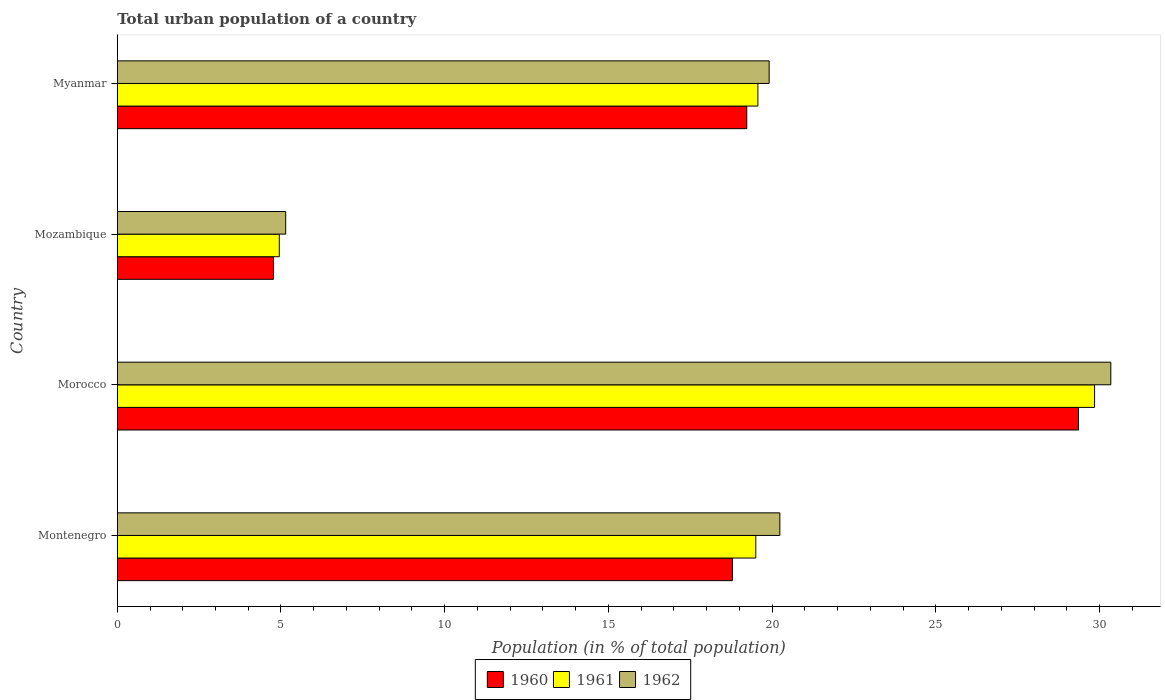How many bars are there on the 3rd tick from the top?
Your answer should be very brief. 3. How many bars are there on the 1st tick from the bottom?
Provide a succinct answer. 3. What is the label of the 1st group of bars from the top?
Your answer should be compact. Myanmar. What is the urban population in 1960 in Myanmar?
Provide a short and direct response. 19.23. Across all countries, what is the maximum urban population in 1960?
Offer a very short reply. 29.36. Across all countries, what is the minimum urban population in 1962?
Your response must be concise. 5.14. In which country was the urban population in 1960 maximum?
Your response must be concise. Morocco. In which country was the urban population in 1962 minimum?
Your answer should be compact. Mozambique. What is the total urban population in 1962 in the graph?
Make the answer very short. 75.64. What is the difference between the urban population in 1960 in Montenegro and that in Mozambique?
Provide a succinct answer. 14.02. What is the difference between the urban population in 1960 in Myanmar and the urban population in 1962 in Morocco?
Your answer should be compact. -11.12. What is the average urban population in 1961 per country?
Keep it short and to the point. 18.47. What is the difference between the urban population in 1962 and urban population in 1960 in Morocco?
Make the answer very short. 0.99. In how many countries, is the urban population in 1960 greater than 22 %?
Offer a very short reply. 1. What is the ratio of the urban population in 1962 in Montenegro to that in Morocco?
Provide a succinct answer. 0.67. Is the difference between the urban population in 1962 in Morocco and Myanmar greater than the difference between the urban population in 1960 in Morocco and Myanmar?
Provide a succinct answer. Yes. What is the difference between the highest and the second highest urban population in 1961?
Give a very brief answer. 10.28. What is the difference between the highest and the lowest urban population in 1961?
Provide a succinct answer. 24.9. In how many countries, is the urban population in 1960 greater than the average urban population in 1960 taken over all countries?
Keep it short and to the point. 3. What does the 1st bar from the bottom in Montenegro represents?
Keep it short and to the point. 1960. Is it the case that in every country, the sum of the urban population in 1961 and urban population in 1962 is greater than the urban population in 1960?
Offer a terse response. Yes. How many bars are there?
Make the answer very short. 12. What is the difference between two consecutive major ticks on the X-axis?
Provide a succinct answer. 5. Are the values on the major ticks of X-axis written in scientific E-notation?
Provide a succinct answer. No. Does the graph contain any zero values?
Your response must be concise. No. How are the legend labels stacked?
Offer a very short reply. Horizontal. What is the title of the graph?
Your answer should be compact. Total urban population of a country. Does "1969" appear as one of the legend labels in the graph?
Ensure brevity in your answer.  No. What is the label or title of the X-axis?
Your answer should be compact. Population (in % of total population). What is the Population (in % of total population) of 1960 in Montenegro?
Provide a short and direct response. 18.79. What is the Population (in % of total population) in 1961 in Montenegro?
Offer a terse response. 19.5. What is the Population (in % of total population) in 1962 in Montenegro?
Provide a succinct answer. 20.24. What is the Population (in % of total population) of 1960 in Morocco?
Ensure brevity in your answer.  29.36. What is the Population (in % of total population) in 1961 in Morocco?
Your answer should be compact. 29.85. What is the Population (in % of total population) of 1962 in Morocco?
Give a very brief answer. 30.34. What is the Population (in % of total population) in 1960 in Mozambique?
Keep it short and to the point. 4.77. What is the Population (in % of total population) of 1961 in Mozambique?
Provide a succinct answer. 4.95. What is the Population (in % of total population) of 1962 in Mozambique?
Your answer should be very brief. 5.14. What is the Population (in % of total population) in 1960 in Myanmar?
Offer a terse response. 19.23. What is the Population (in % of total population) in 1961 in Myanmar?
Offer a terse response. 19.57. What is the Population (in % of total population) of 1962 in Myanmar?
Offer a very short reply. 19.91. Across all countries, what is the maximum Population (in % of total population) in 1960?
Provide a succinct answer. 29.36. Across all countries, what is the maximum Population (in % of total population) in 1961?
Your answer should be very brief. 29.85. Across all countries, what is the maximum Population (in % of total population) in 1962?
Your answer should be compact. 30.34. Across all countries, what is the minimum Population (in % of total population) of 1960?
Your answer should be very brief. 4.77. Across all countries, what is the minimum Population (in % of total population) of 1961?
Give a very brief answer. 4.95. Across all countries, what is the minimum Population (in % of total population) of 1962?
Make the answer very short. 5.14. What is the total Population (in % of total population) in 1960 in the graph?
Your response must be concise. 72.14. What is the total Population (in % of total population) in 1961 in the graph?
Give a very brief answer. 73.87. What is the total Population (in % of total population) of 1962 in the graph?
Provide a succinct answer. 75.64. What is the difference between the Population (in % of total population) of 1960 in Montenegro and that in Morocco?
Make the answer very short. -10.57. What is the difference between the Population (in % of total population) in 1961 in Montenegro and that in Morocco?
Provide a short and direct response. -10.35. What is the difference between the Population (in % of total population) of 1962 in Montenegro and that in Morocco?
Keep it short and to the point. -10.11. What is the difference between the Population (in % of total population) in 1960 in Montenegro and that in Mozambique?
Give a very brief answer. 14.02. What is the difference between the Population (in % of total population) in 1961 in Montenegro and that in Mozambique?
Keep it short and to the point. 14.55. What is the difference between the Population (in % of total population) of 1962 in Montenegro and that in Mozambique?
Provide a short and direct response. 15.09. What is the difference between the Population (in % of total population) of 1960 in Montenegro and that in Myanmar?
Ensure brevity in your answer.  -0.44. What is the difference between the Population (in % of total population) of 1961 in Montenegro and that in Myanmar?
Provide a short and direct response. -0.06. What is the difference between the Population (in % of total population) of 1962 in Montenegro and that in Myanmar?
Offer a very short reply. 0.33. What is the difference between the Population (in % of total population) of 1960 in Morocco and that in Mozambique?
Offer a very short reply. 24.59. What is the difference between the Population (in % of total population) in 1961 in Morocco and that in Mozambique?
Offer a terse response. 24.9. What is the difference between the Population (in % of total population) in 1962 in Morocco and that in Mozambique?
Ensure brevity in your answer.  25.2. What is the difference between the Population (in % of total population) in 1960 in Morocco and that in Myanmar?
Provide a succinct answer. 10.13. What is the difference between the Population (in % of total population) in 1961 in Morocco and that in Myanmar?
Keep it short and to the point. 10.28. What is the difference between the Population (in % of total population) in 1962 in Morocco and that in Myanmar?
Your response must be concise. 10.44. What is the difference between the Population (in % of total population) of 1960 in Mozambique and that in Myanmar?
Make the answer very short. -14.46. What is the difference between the Population (in % of total population) in 1961 in Mozambique and that in Myanmar?
Provide a short and direct response. -14.62. What is the difference between the Population (in % of total population) of 1962 in Mozambique and that in Myanmar?
Provide a succinct answer. -14.77. What is the difference between the Population (in % of total population) of 1960 in Montenegro and the Population (in % of total population) of 1961 in Morocco?
Your answer should be compact. -11.06. What is the difference between the Population (in % of total population) in 1960 in Montenegro and the Population (in % of total population) in 1962 in Morocco?
Ensure brevity in your answer.  -11.56. What is the difference between the Population (in % of total population) in 1961 in Montenegro and the Population (in % of total population) in 1962 in Morocco?
Offer a very short reply. -10.84. What is the difference between the Population (in % of total population) of 1960 in Montenegro and the Population (in % of total population) of 1961 in Mozambique?
Your answer should be very brief. 13.84. What is the difference between the Population (in % of total population) in 1960 in Montenegro and the Population (in % of total population) in 1962 in Mozambique?
Keep it short and to the point. 13.64. What is the difference between the Population (in % of total population) of 1961 in Montenegro and the Population (in % of total population) of 1962 in Mozambique?
Give a very brief answer. 14.36. What is the difference between the Population (in % of total population) of 1960 in Montenegro and the Population (in % of total population) of 1961 in Myanmar?
Make the answer very short. -0.78. What is the difference between the Population (in % of total population) in 1960 in Montenegro and the Population (in % of total population) in 1962 in Myanmar?
Provide a short and direct response. -1.12. What is the difference between the Population (in % of total population) of 1961 in Montenegro and the Population (in % of total population) of 1962 in Myanmar?
Give a very brief answer. -0.41. What is the difference between the Population (in % of total population) of 1960 in Morocco and the Population (in % of total population) of 1961 in Mozambique?
Offer a terse response. 24.41. What is the difference between the Population (in % of total population) of 1960 in Morocco and the Population (in % of total population) of 1962 in Mozambique?
Offer a terse response. 24.21. What is the difference between the Population (in % of total population) of 1961 in Morocco and the Population (in % of total population) of 1962 in Mozambique?
Your response must be concise. 24.7. What is the difference between the Population (in % of total population) in 1960 in Morocco and the Population (in % of total population) in 1961 in Myanmar?
Offer a very short reply. 9.79. What is the difference between the Population (in % of total population) in 1960 in Morocco and the Population (in % of total population) in 1962 in Myanmar?
Provide a short and direct response. 9.45. What is the difference between the Population (in % of total population) of 1961 in Morocco and the Population (in % of total population) of 1962 in Myanmar?
Keep it short and to the point. 9.94. What is the difference between the Population (in % of total population) of 1960 in Mozambique and the Population (in % of total population) of 1961 in Myanmar?
Make the answer very short. -14.8. What is the difference between the Population (in % of total population) of 1960 in Mozambique and the Population (in % of total population) of 1962 in Myanmar?
Ensure brevity in your answer.  -15.14. What is the difference between the Population (in % of total population) of 1961 in Mozambique and the Population (in % of total population) of 1962 in Myanmar?
Your answer should be compact. -14.96. What is the average Population (in % of total population) of 1960 per country?
Provide a succinct answer. 18.04. What is the average Population (in % of total population) of 1961 per country?
Keep it short and to the point. 18.47. What is the average Population (in % of total population) of 1962 per country?
Give a very brief answer. 18.91. What is the difference between the Population (in % of total population) in 1960 and Population (in % of total population) in 1961 in Montenegro?
Offer a very short reply. -0.71. What is the difference between the Population (in % of total population) of 1960 and Population (in % of total population) of 1962 in Montenegro?
Provide a succinct answer. -1.45. What is the difference between the Population (in % of total population) in 1961 and Population (in % of total population) in 1962 in Montenegro?
Ensure brevity in your answer.  -0.73. What is the difference between the Population (in % of total population) of 1960 and Population (in % of total population) of 1961 in Morocco?
Your answer should be compact. -0.49. What is the difference between the Population (in % of total population) in 1960 and Population (in % of total population) in 1962 in Morocco?
Offer a very short reply. -0.99. What is the difference between the Population (in % of total population) of 1961 and Population (in % of total population) of 1962 in Morocco?
Offer a terse response. -0.5. What is the difference between the Population (in % of total population) of 1960 and Population (in % of total population) of 1961 in Mozambique?
Your answer should be compact. -0.18. What is the difference between the Population (in % of total population) of 1960 and Population (in % of total population) of 1962 in Mozambique?
Ensure brevity in your answer.  -0.38. What is the difference between the Population (in % of total population) of 1961 and Population (in % of total population) of 1962 in Mozambique?
Make the answer very short. -0.2. What is the difference between the Population (in % of total population) of 1960 and Population (in % of total population) of 1961 in Myanmar?
Make the answer very short. -0.34. What is the difference between the Population (in % of total population) in 1960 and Population (in % of total population) in 1962 in Myanmar?
Offer a very short reply. -0.68. What is the difference between the Population (in % of total population) of 1961 and Population (in % of total population) of 1962 in Myanmar?
Provide a short and direct response. -0.34. What is the ratio of the Population (in % of total population) in 1960 in Montenegro to that in Morocco?
Your answer should be compact. 0.64. What is the ratio of the Population (in % of total population) of 1961 in Montenegro to that in Morocco?
Make the answer very short. 0.65. What is the ratio of the Population (in % of total population) in 1962 in Montenegro to that in Morocco?
Offer a very short reply. 0.67. What is the ratio of the Population (in % of total population) of 1960 in Montenegro to that in Mozambique?
Your answer should be compact. 3.94. What is the ratio of the Population (in % of total population) in 1961 in Montenegro to that in Mozambique?
Your answer should be very brief. 3.94. What is the ratio of the Population (in % of total population) in 1962 in Montenegro to that in Mozambique?
Your answer should be very brief. 3.93. What is the ratio of the Population (in % of total population) in 1960 in Montenegro to that in Myanmar?
Your response must be concise. 0.98. What is the ratio of the Population (in % of total population) in 1961 in Montenegro to that in Myanmar?
Give a very brief answer. 1. What is the ratio of the Population (in % of total population) of 1962 in Montenegro to that in Myanmar?
Offer a very short reply. 1.02. What is the ratio of the Population (in % of total population) of 1960 in Morocco to that in Mozambique?
Make the answer very short. 6.16. What is the ratio of the Population (in % of total population) of 1961 in Morocco to that in Mozambique?
Make the answer very short. 6.03. What is the ratio of the Population (in % of total population) in 1962 in Morocco to that in Mozambique?
Give a very brief answer. 5.9. What is the ratio of the Population (in % of total population) of 1960 in Morocco to that in Myanmar?
Offer a very short reply. 1.53. What is the ratio of the Population (in % of total population) in 1961 in Morocco to that in Myanmar?
Provide a succinct answer. 1.53. What is the ratio of the Population (in % of total population) of 1962 in Morocco to that in Myanmar?
Offer a very short reply. 1.52. What is the ratio of the Population (in % of total population) in 1960 in Mozambique to that in Myanmar?
Make the answer very short. 0.25. What is the ratio of the Population (in % of total population) of 1961 in Mozambique to that in Myanmar?
Keep it short and to the point. 0.25. What is the ratio of the Population (in % of total population) of 1962 in Mozambique to that in Myanmar?
Provide a succinct answer. 0.26. What is the difference between the highest and the second highest Population (in % of total population) in 1960?
Make the answer very short. 10.13. What is the difference between the highest and the second highest Population (in % of total population) of 1961?
Your answer should be compact. 10.28. What is the difference between the highest and the second highest Population (in % of total population) of 1962?
Provide a succinct answer. 10.11. What is the difference between the highest and the lowest Population (in % of total population) of 1960?
Your answer should be very brief. 24.59. What is the difference between the highest and the lowest Population (in % of total population) in 1961?
Provide a succinct answer. 24.9. What is the difference between the highest and the lowest Population (in % of total population) of 1962?
Offer a very short reply. 25.2. 